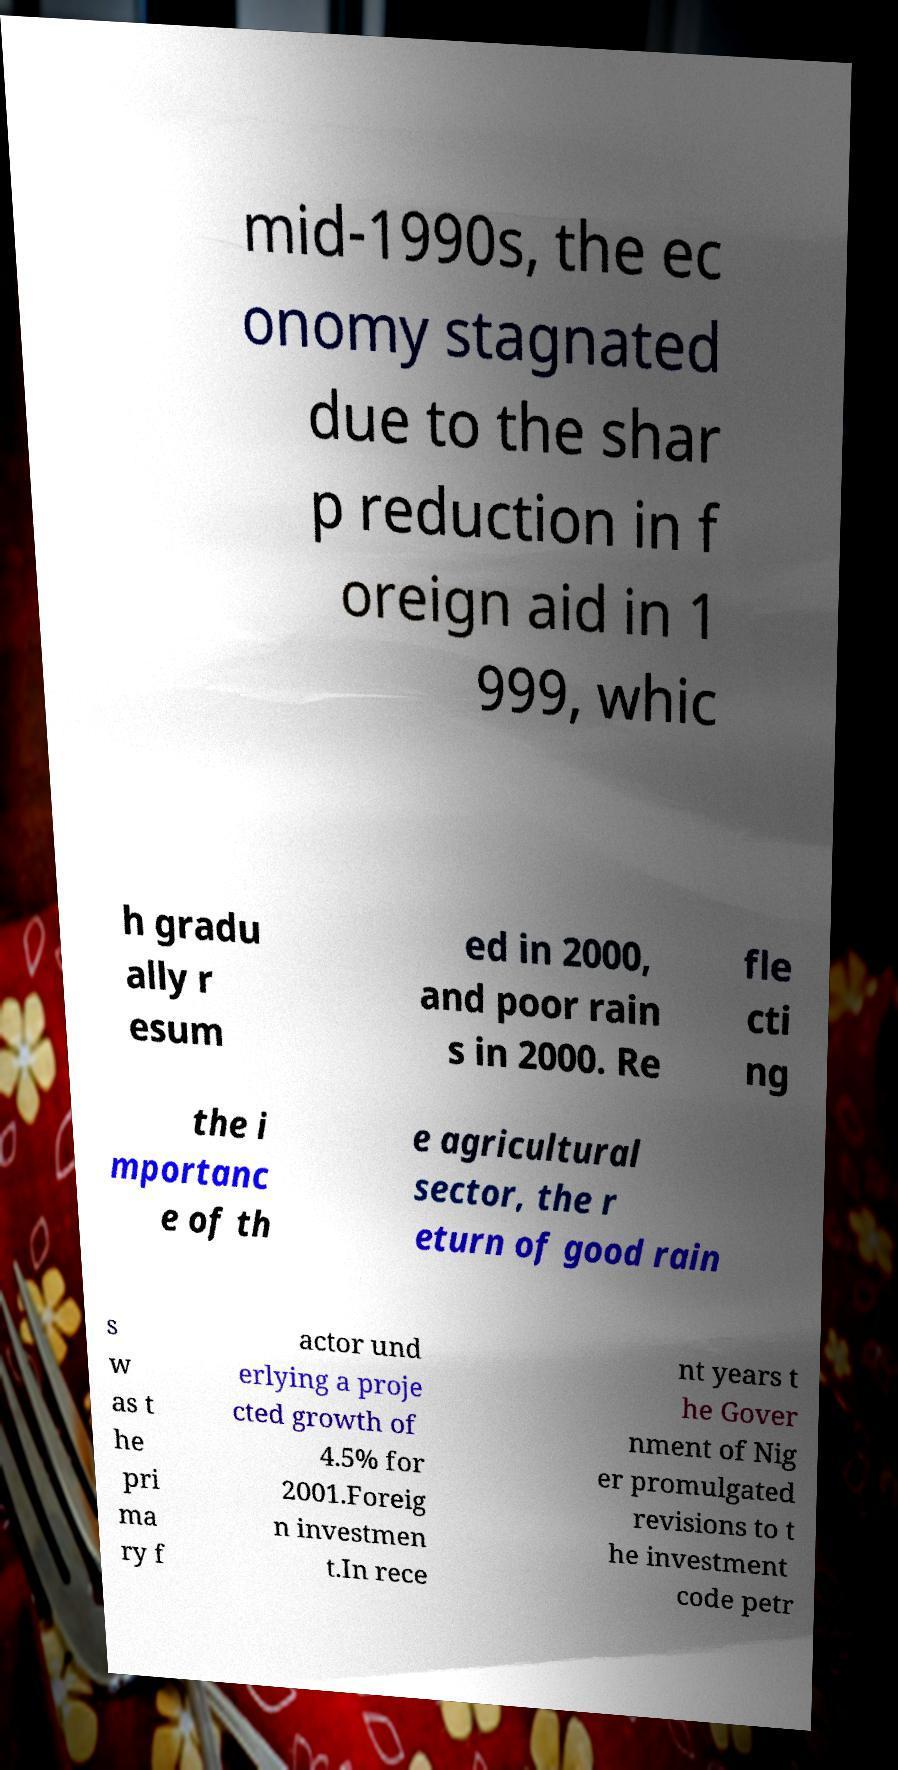I need the written content from this picture converted into text. Can you do that? mid-1990s, the ec onomy stagnated due to the shar p reduction in f oreign aid in 1 999, whic h gradu ally r esum ed in 2000, and poor rain s in 2000. Re fle cti ng the i mportanc e of th e agricultural sector, the r eturn of good rain s w as t he pri ma ry f actor und erlying a proje cted growth of 4.5% for 2001.Foreig n investmen t.In rece nt years t he Gover nment of Nig er promulgated revisions to t he investment code petr 